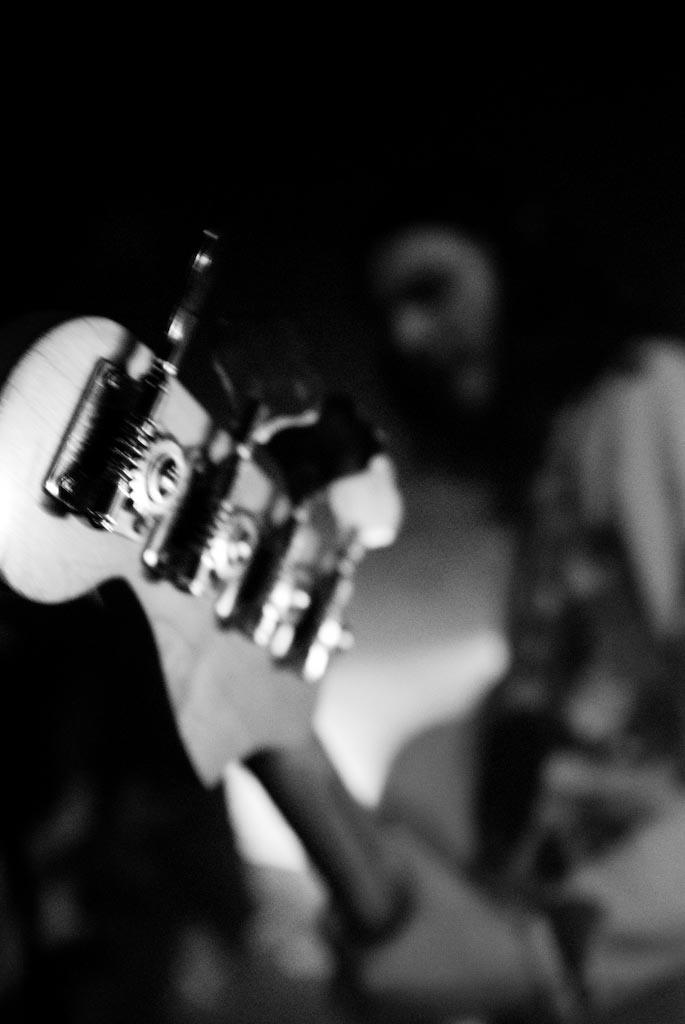What is the main subject of the image? There is a person in the image. What is the person holding in the image? The person is holding a guitar. What color scheme is used in the image? The image is in black and white color. What type of bat can be seen flying in the image? There is no bat present in the image; it features a person holding a guitar in a black and white setting. How many fowls are visible in the image? There are no fowls present in the image. 